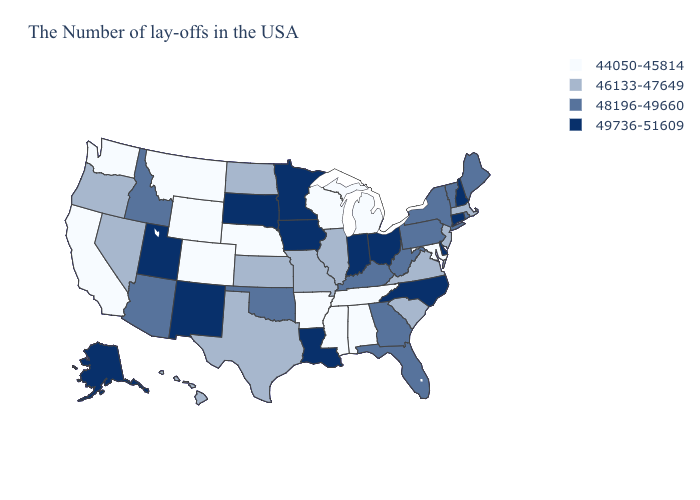Which states hav the highest value in the Northeast?
Short answer required. New Hampshire, Connecticut. Among the states that border Kentucky , which have the highest value?
Quick response, please. Ohio, Indiana. What is the highest value in the USA?
Keep it brief. 49736-51609. Does Wisconsin have a higher value than Ohio?
Be succinct. No. What is the lowest value in the USA?
Keep it brief. 44050-45814. What is the value of New Mexico?
Answer briefly. 49736-51609. What is the value of Maryland?
Concise answer only. 44050-45814. Name the states that have a value in the range 44050-45814?
Be succinct. Maryland, Michigan, Alabama, Tennessee, Wisconsin, Mississippi, Arkansas, Nebraska, Wyoming, Colorado, Montana, California, Washington. Name the states that have a value in the range 46133-47649?
Quick response, please. Massachusetts, New Jersey, Virginia, South Carolina, Illinois, Missouri, Kansas, Texas, North Dakota, Nevada, Oregon, Hawaii. What is the lowest value in the Northeast?
Concise answer only. 46133-47649. Name the states that have a value in the range 46133-47649?
Give a very brief answer. Massachusetts, New Jersey, Virginia, South Carolina, Illinois, Missouri, Kansas, Texas, North Dakota, Nevada, Oregon, Hawaii. Does Arkansas have the highest value in the South?
Concise answer only. No. Does the map have missing data?
Give a very brief answer. No. Which states hav the highest value in the Northeast?
Keep it brief. New Hampshire, Connecticut. Does Connecticut have the lowest value in the Northeast?
Answer briefly. No. 